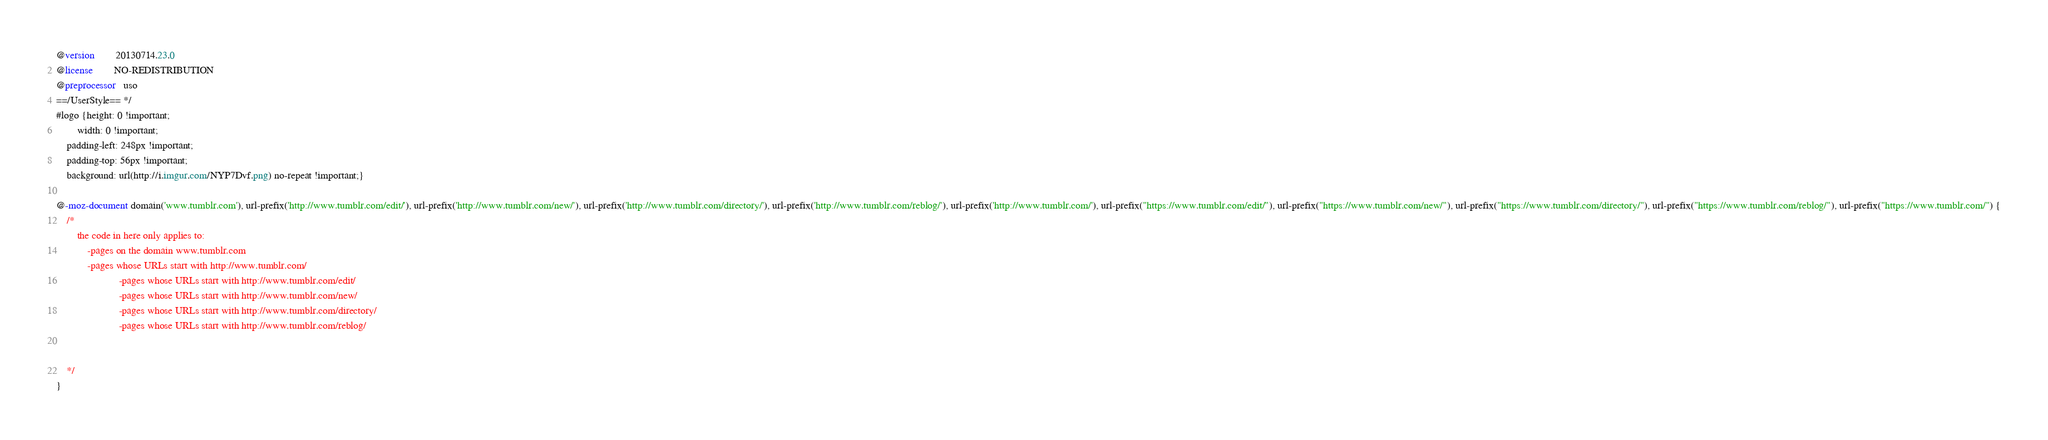<code> <loc_0><loc_0><loc_500><loc_500><_CSS_>@version        20130714.23.0
@license        NO-REDISTRIBUTION
@preprocessor   uso
==/UserStyle== */
#logo {height: 0 !important;
        width: 0 !important;
	padding-left: 248px !important;
	padding-top: 56px !important;
	background: url(http://i.imgur.com/NYP7Dvf.png) no-repeat !important;}

@-moz-document domain('www.tumblr.com'), url-prefix('http://www.tumblr.com/edit/'), url-prefix('http://www.tumblr.com/new/'), url-prefix('http://www.tumblr.com/directory/'), url-prefix('http://www.tumblr.com/reblog/'), url-prefix('http://www.tumblr.com/'), url-prefix("https://www.tumblr.com/edit/"), url-prefix("https://www.tumblr.com/new/"), url-prefix("https://www.tumblr.com/directory/"), url-prefix("https://www.tumblr.com/reblog/"), url-prefix("https://www.tumblr.com/") {
	/* 
		the code in here only applies to:
			-pages on the domain www.tumblr.com
			-pages whose URLs start with http://www.tumblr.com/
                        -pages whose URLs start with http://www.tumblr.com/edit/
                        -pages whose URLs start with http://www.tumblr.com/new/
                        -pages whose URLs start with http://www.tumblr.com/directory/
                        -pages whose URLs start with http://www.tumblr.com/reblog/


	*/
}</code> 